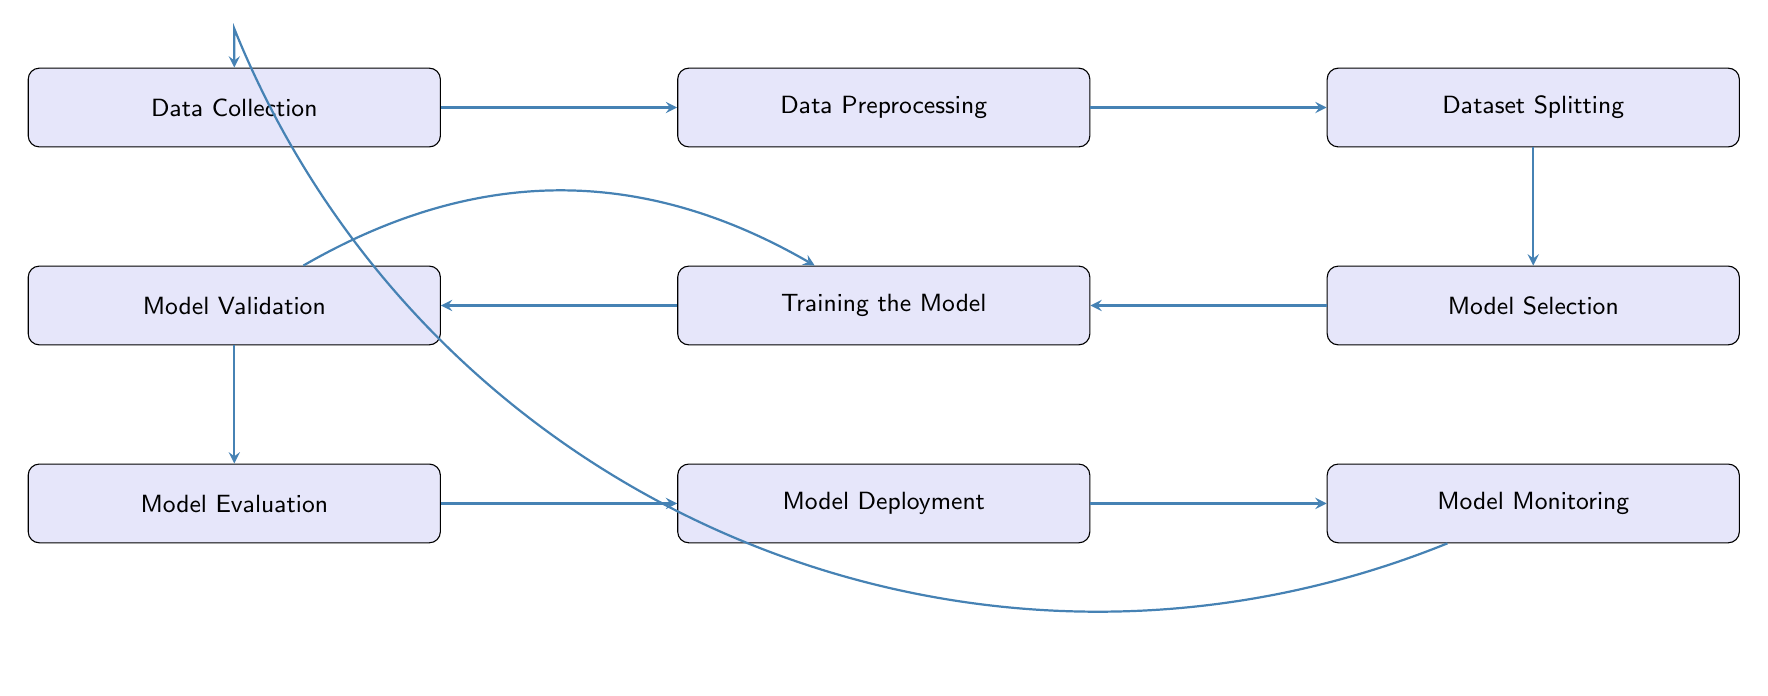What is the first step in the model training pipeline? The diagram indicates that the first step in the model training pipeline is "Data Collection." This can be concluded by observing the initial position in the flowchart where the arrows begin.
Answer: Data Collection How many nodes are in the diagram? By counting the distinct boxes (nodes) in the flowchart, we see there are nine nodes representing different stages in the pipeline. Each of these stages is connected by arrows.
Answer: Nine What is the last step of the model training pipeline? The last step, as indicated by the flow of arrows leading to the final box, is "Model Monitoring." This step is at the furthest right end of the flowchart's setup.
Answer: Model Monitoring Which two steps are directly connected before "Model Evaluation"? Observing the arrows, we see that "Model Validation" and "Training the Model" are linked directly before "Model Evaluation," indicating they are sequential steps in the process.
Answer: Model Validation and Training the Model What does the arrow from "Model Validation" to "Training the Model" indicate? The bent arrow from "Model Validation" back to "Training the Model" suggests that model validation leads to revisiting the training stage, which is typically done for tuning hyperparameters based on validation feedback.
Answer: Iterative tuning Which models might be selected in the "Model Selection" step? The "Model Selection" step notes that models such as ResNet, YOLO, or EfficientNet can be chosen. These model architectures represent different approaches to computer vision tasks.
Answer: ResNet, YOLO, EfficientNet In what stage is image data cleaned and transformed? The flowchart shows that "Data Preprocessing" is the stage where image data is cleaned and transformed. This step typically involves various preparations necessary for effective model training.
Answer: Data Preprocessing Where do the final evaluations take place in the flow? The final evaluations occur in "Model Evaluation," where the performance of the model is assessed using various metrics. This is the stage right before deployment, as indicated by the directed arrows.
Answer: Model Evaluation 